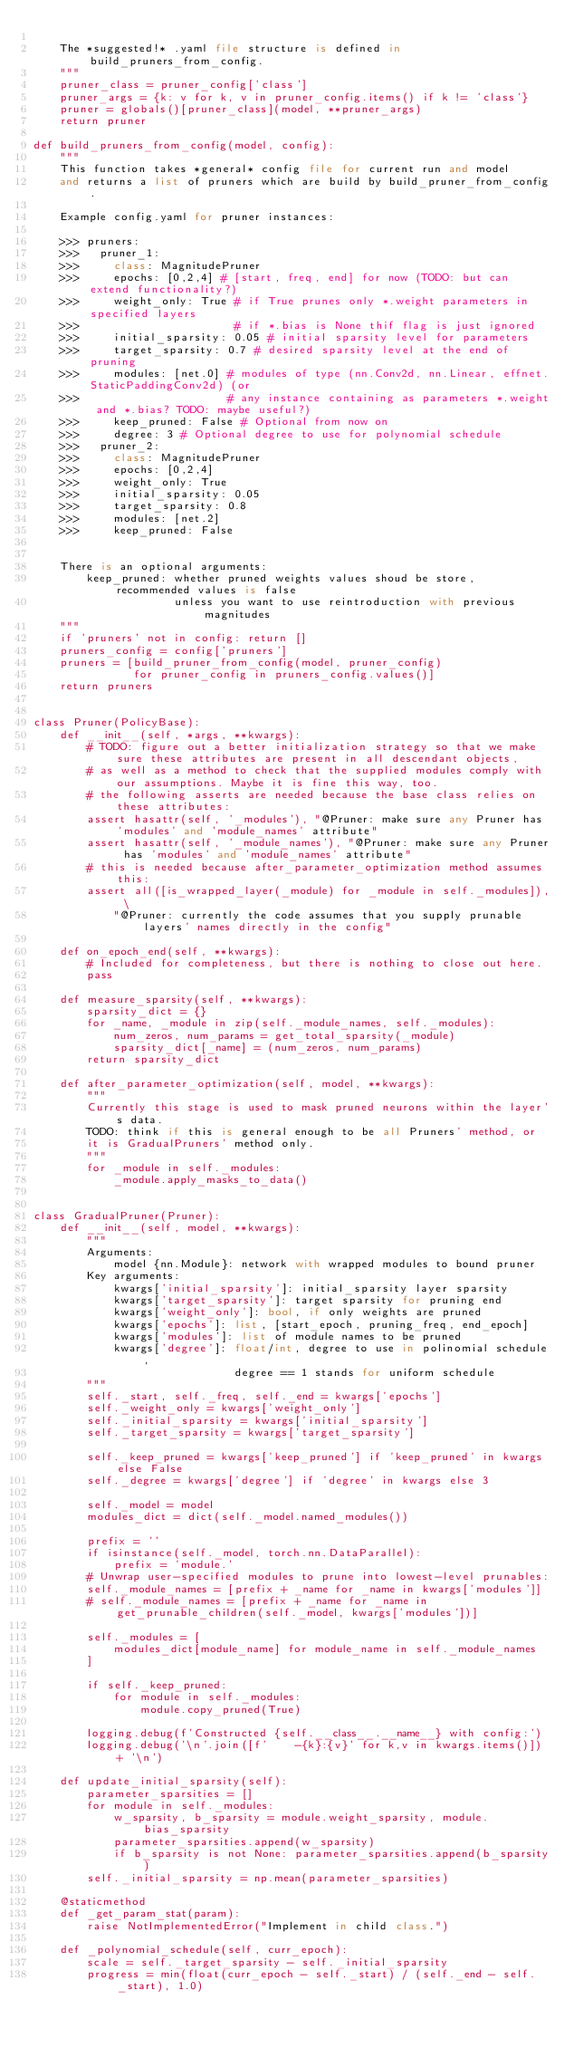<code> <loc_0><loc_0><loc_500><loc_500><_Python_>
    The *suggested!* .yaml file structure is defined in build_pruners_from_config.
    """
    pruner_class = pruner_config['class']
    pruner_args = {k: v for k, v in pruner_config.items() if k != 'class'}
    pruner = globals()[pruner_class](model, **pruner_args)
    return pruner

def build_pruners_from_config(model, config):
    """
    This function takes *general* config file for current run and model 
    and returns a list of pruners which are build by build_pruner_from_config.

    Example config.yaml for pruner instances:

    >>> pruners:
    >>>   pruner_1:
    >>>     class: MagnitudePruner
    >>>     epochs: [0,2,4] # [start, freq, end] for now (TODO: but can extend functionality?)
    >>>     weight_only: True # if True prunes only *.weight parameters in specified layers
    >>>                       # if *.bias is None thif flag is just ignored
    >>>     initial_sparsity: 0.05 # initial sparsity level for parameters
    >>>     target_sparsity: 0.7 # desired sparsity level at the end of pruning
    >>>     modules: [net.0] # modules of type (nn.Conv2d, nn.Linear, effnet.StaticPaddingConv2d) (or
    >>>                      # any instance containing as parameters *.weight and *.bias? TODO: maybe useful?)
    >>>     keep_pruned: False # Optional from now on
    >>>     degree: 3 # Optional degree to use for polynomial schedule
    >>>   pruner_2:
    >>>     class: MagnitudePruner
    >>>     epochs: [0,2,4]
    >>>     weight_only: True
    >>>     initial_sparsity: 0.05
    >>>     target_sparsity: 0.8
    >>>     modules: [net.2]
    >>>     keep_pruned: False


    There is an optional arguments:
        keep_pruned: whether pruned weights values shoud be store, recommended values is false 
                     unless you want to use reintroduction with previous magnitudes
    """
    if 'pruners' not in config: return []
    pruners_config = config['pruners']
    pruners = [build_pruner_from_config(model, pruner_config) 
               for pruner_config in pruners_config.values()]
    return pruners


class Pruner(PolicyBase):
    def __init__(self, *args, **kwargs):
        # TODO: figure out a better initialization strategy so that we make sure these attributes are present in all descendant objects,
        # as well as a method to check that the supplied modules comply with our assumptions. Maybe it is fine this way, too.
        # the following asserts are needed because the base class relies on these attributes:
        assert hasattr(self, '_modules'), "@Pruner: make sure any Pruner has 'modules' and 'module_names' attribute"
        assert hasattr(self, '_module_names'), "@Pruner: make sure any Pruner has 'modules' and 'module_names' attribute"
        # this is needed because after_parameter_optimization method assumes this:
        assert all([is_wrapped_layer(_module) for _module in self._modules]), \
            "@Pruner: currently the code assumes that you supply prunable layers' names directly in the config"

    def on_epoch_end(self, **kwargs):
        # Included for completeness, but there is nothing to close out here.
        pass

    def measure_sparsity(self, **kwargs):
        sparsity_dict = {}
        for _name, _module in zip(self._module_names, self._modules):
            num_zeros, num_params = get_total_sparsity(_module)
            sparsity_dict[_name] = (num_zeros, num_params)
        return sparsity_dict

    def after_parameter_optimization(self, model, **kwargs):
        """
        Currently this stage is used to mask pruned neurons within the layer's data.
        TODO: think if this is general enough to be all Pruners' method, or
        it is GradualPruners' method only.
        """
        for _module in self._modules:
            _module.apply_masks_to_data()


class GradualPruner(Pruner):
    def __init__(self, model, **kwargs):
        """
        Arguments:
            model {nn.Module}: network with wrapped modules to bound pruner
        Key arguments:
            kwargs['initial_sparsity']: initial_sparsity layer sparsity
            kwargs['target_sparsity']: target sparsity for pruning end
            kwargs['weight_only']: bool, if only weights are pruned
            kwargs['epochs']: list, [start_epoch, pruning_freq, end_epoch]
            kwargs['modules']: list of module names to be pruned
            kwargs['degree']: float/int, degree to use in polinomial schedule, 
                              degree == 1 stands for uniform schedule
        """
        self._start, self._freq, self._end = kwargs['epochs']
        self._weight_only = kwargs['weight_only']
        self._initial_sparsity = kwargs['initial_sparsity']
        self._target_sparsity = kwargs['target_sparsity']

        self._keep_pruned = kwargs['keep_pruned'] if 'keep_pruned' in kwargs else False
        self._degree = kwargs['degree'] if 'degree' in kwargs else 3

        self._model = model
        modules_dict = dict(self._model.named_modules())

        prefix = ''
        if isinstance(self._model, torch.nn.DataParallel):
            prefix = 'module.'
        # Unwrap user-specified modules to prune into lowest-level prunables:
        self._module_names = [prefix + _name for _name in kwargs['modules']]
        # self._module_names = [prefix + _name for _name in get_prunable_children(self._model, kwargs['modules'])]

        self._modules = [
            modules_dict[module_name] for module_name in self._module_names
        ]

        if self._keep_pruned:
            for module in self._modules:
                module.copy_pruned(True)

        logging.debug(f'Constructed {self.__class__.__name__} with config:')
        logging.debug('\n'.join([f'    -{k}:{v}' for k,v in kwargs.items()]) + '\n')

    def update_initial_sparsity(self):
        parameter_sparsities = []
        for module in self._modules:
            w_sparsity, b_sparsity = module.weight_sparsity, module.bias_sparsity
            parameter_sparsities.append(w_sparsity)
            if b_sparsity is not None: parameter_sparsities.append(b_sparsity)
        self._initial_sparsity = np.mean(parameter_sparsities)

    @staticmethod
    def _get_param_stat(param):
        raise NotImplementedError("Implement in child class.")

    def _polynomial_schedule(self, curr_epoch):
        scale = self._target_sparsity - self._initial_sparsity
        progress = min(float(curr_epoch - self._start) / (self._end - self._start), 1.0)</code> 